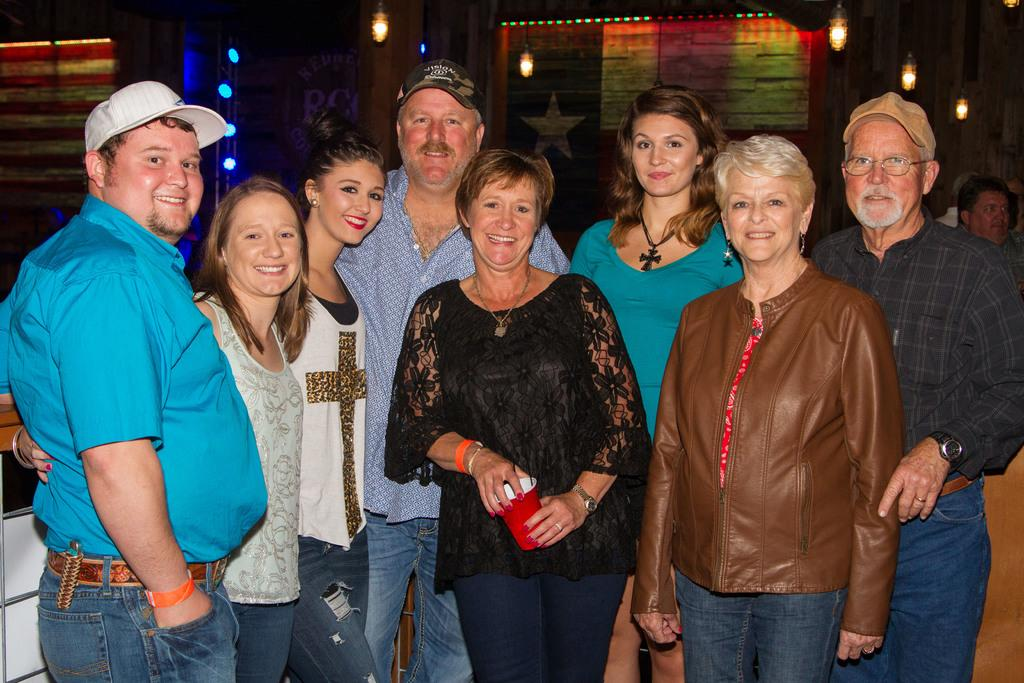How many people are in the image? There is a group of people standing in the image, but the exact number cannot be determined from the provided facts. What can be seen at the top of the image? There are lights visible at the top of the image. Is there a river flowing through the image? There is no mention of a river in the provided facts, so it cannot be determined if there is one in the image. 